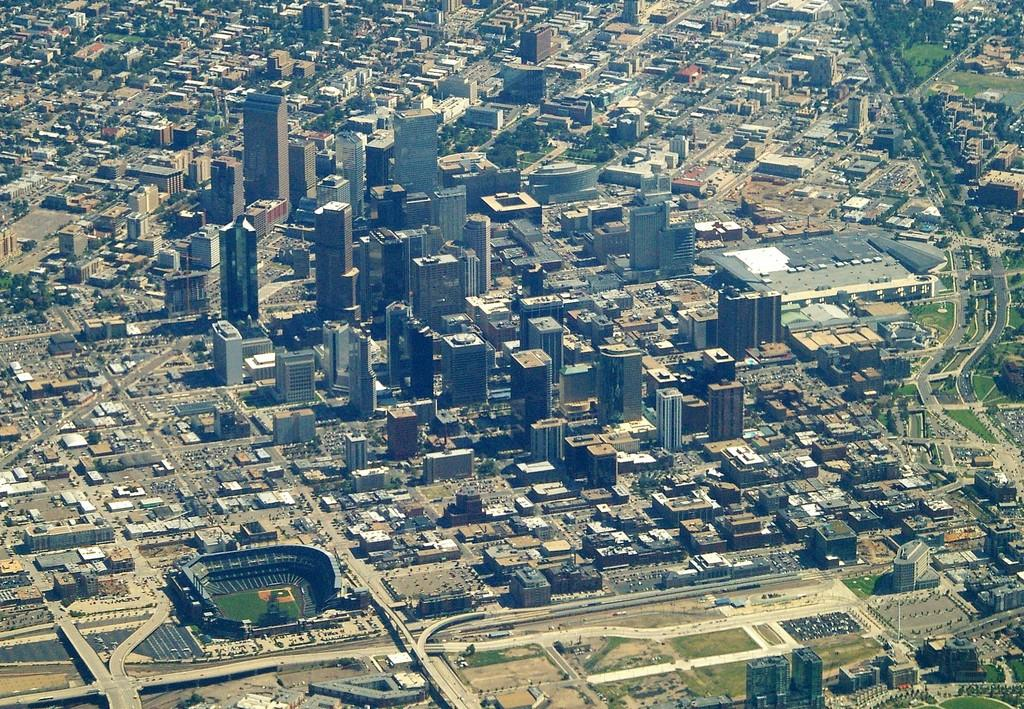What type of view is depicted in the image? The image is an aerial view. What structures can be seen in the image? There are buildings and towers in the image. What type of infrastructure is visible in the image? There are roads in the image. What type of vegetation is present in the image? There are trees in the image. What type of recreational facility is visible in the image? There is a stadium in the image. What type of cannon is used to create the aerial view in the image? There is no cannon present in the image; it is an aerial photograph or digital image taken from above. What season is depicted in the image? The provided facts do not mention the season, so it cannot be determined from the image. 